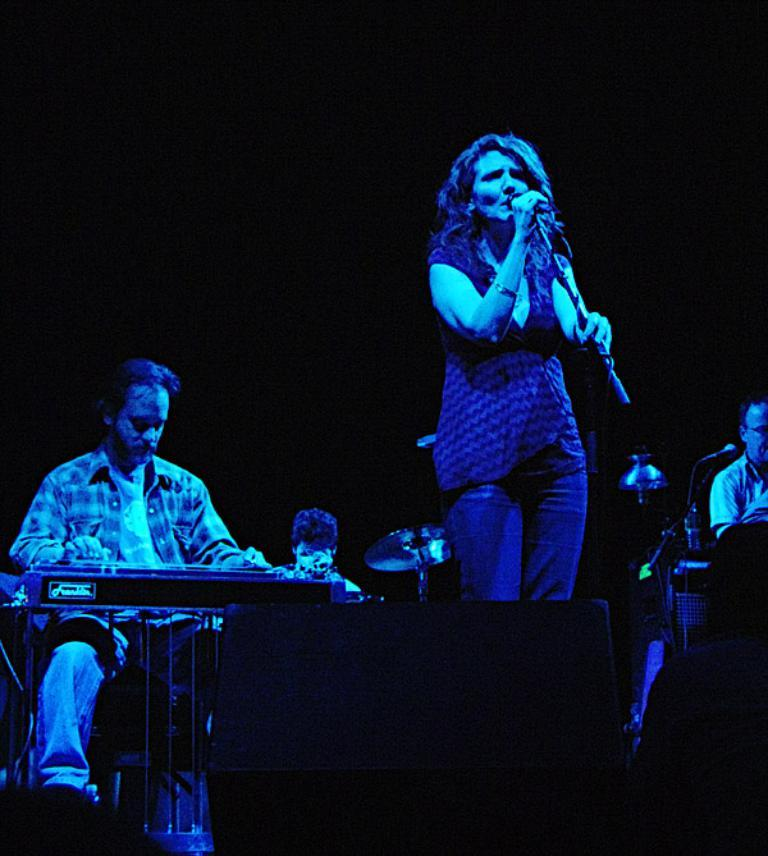What are the people in the image doing? The people in the image are playing musical instruments. What is the lady in the image doing while the others play instruments? The lady is singing a song in the image. How is the lady's voice being amplified? The lady is using a microphone. What color is the background of the image? The background of the image is black. What type of school can be seen in the background of the image? There is no school visible in the background of the image; the background is black. What is the lady's reaction to the surprise in the image? There is no surprise mentioned or depicted in the image. 